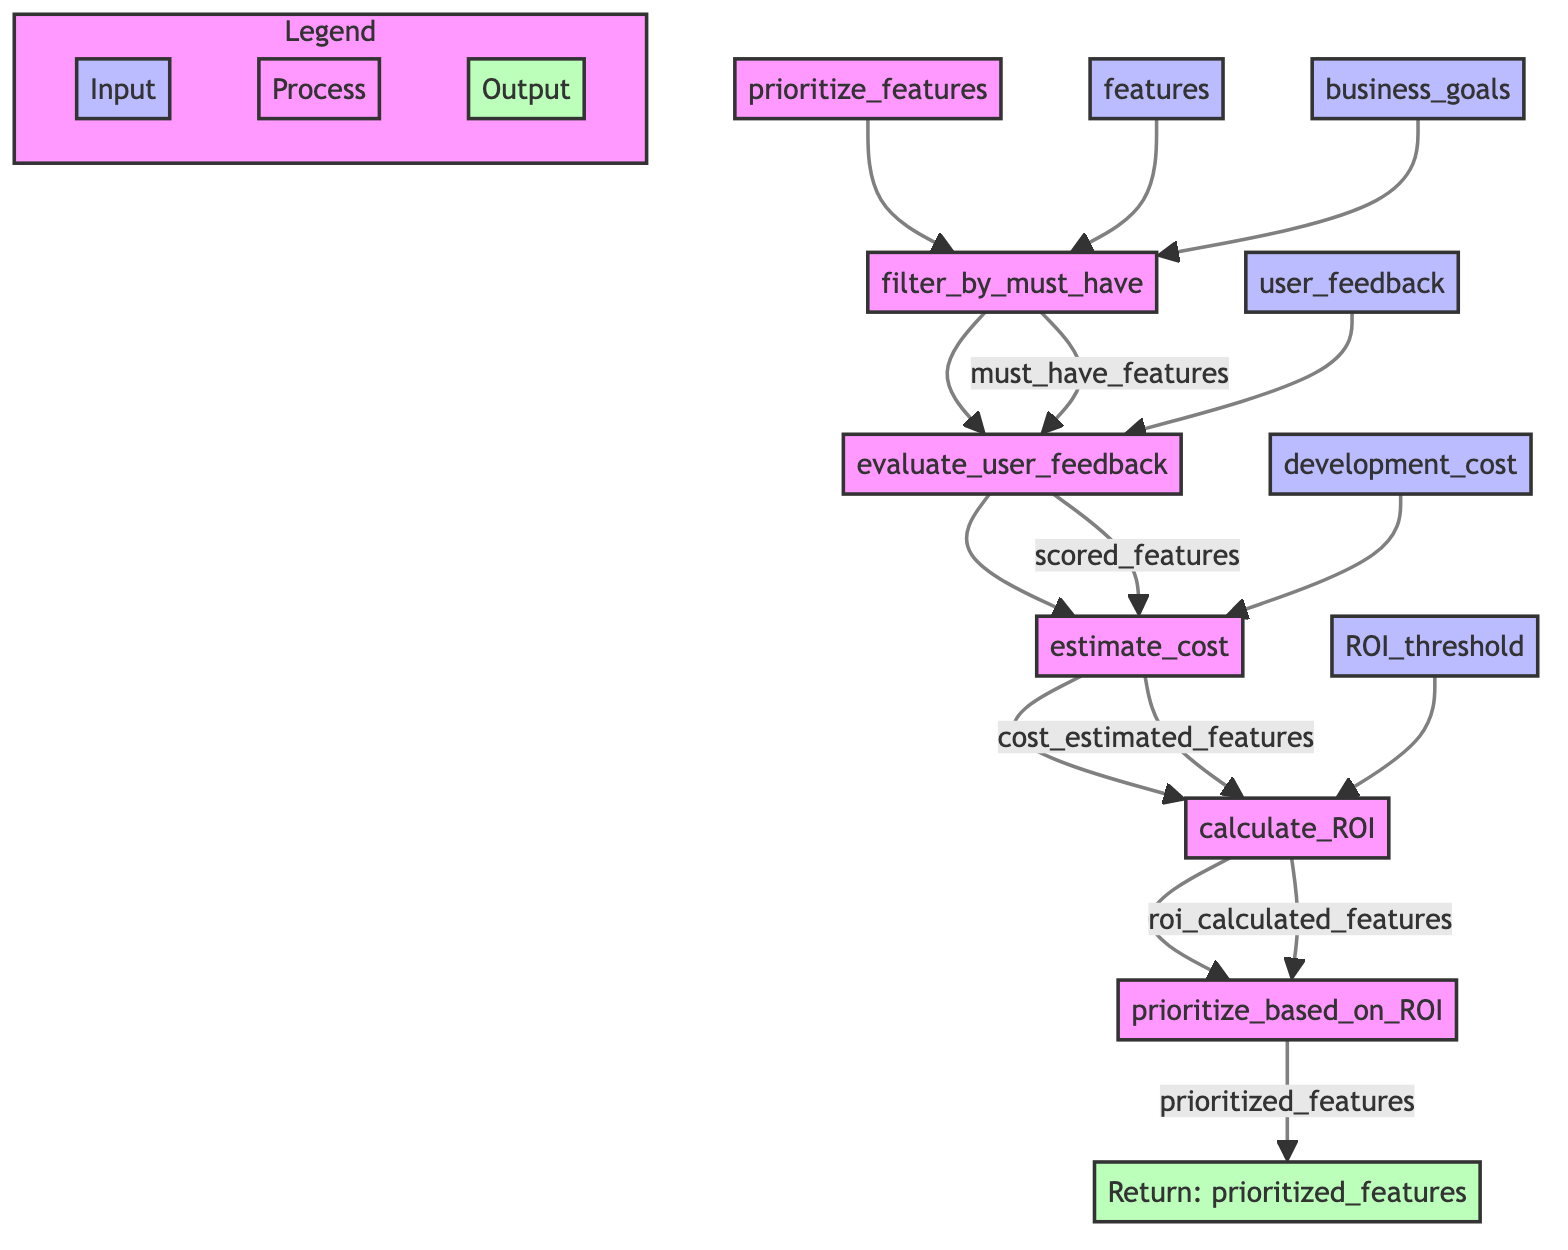What is the name of the function in the diagram? The diagram shows the main function as "prioritize_features" as indicated at the top of the flowchart.
Answer: prioritize_features How many steps are there in the process? The diagram lists five specific steps that take place sequentially after the initial function call, which are shown in boxes connected by arrows.
Answer: 5 What does the first step output? The first step, named "filter_by_must_have," outputs "must_have_features," as indicated by the flow from this step to the next in the diagram.
Answer: must_have_features What is the input to the "calculate_ROI" step? The input to the "calculate_ROI" step is "cost_estimated_features," which is the output of the previous step "estimate_cost." This is visible from the flow of arrows leading into this box.
Answer: cost_estimated_features Which step ranks features? The step that ranks features is "prioritize_based_on_ROI," as it directly follows the calculation of ROI in the flowchart and is labeled to show its function.
Answer: prioritize_based_on_ROI How many inputs does the "evaluate_user_feedback" step have? The step "evaluate_user_feedback" has three inputs shown in the diagram: "must_have_features" and "user_feedback" leading into it. Thus, there are two inputs effectively reaching this step.
Answer: 2 What is the output of the "estimate_cost" step? The "estimate_cost" step outputs "cost_estimated_features," indicated in the diagram by the flow from this step to the next.
Answer: cost_estimated_features Which parameter acts as a threshold in the process? The parameter that acts as a threshold is "ROI_threshold," which is used in the "calculate_ROI" step to determine feature prioritization based on ROI calculations.
Answer: ROI_threshold Which node comes after "evaluate_user_feedback"? The node that comes after "evaluate_user_feedback" is "estimate_cost," as shown by the arrow connecting the two steps in the flowchart.
Answer: estimate_cost 